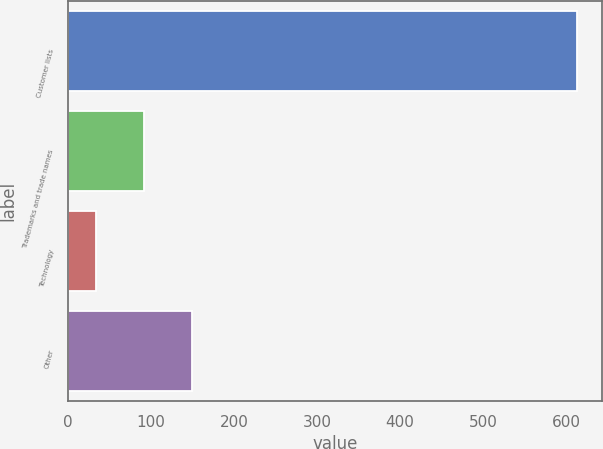Convert chart to OTSL. <chart><loc_0><loc_0><loc_500><loc_500><bar_chart><fcel>Customer lists<fcel>Trademarks and trade names<fcel>Technology<fcel>Other<nl><fcel>613<fcel>91.9<fcel>34<fcel>149.8<nl></chart> 